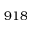Convert formula to latex. <formula><loc_0><loc_0><loc_500><loc_500>9 1 8</formula> 